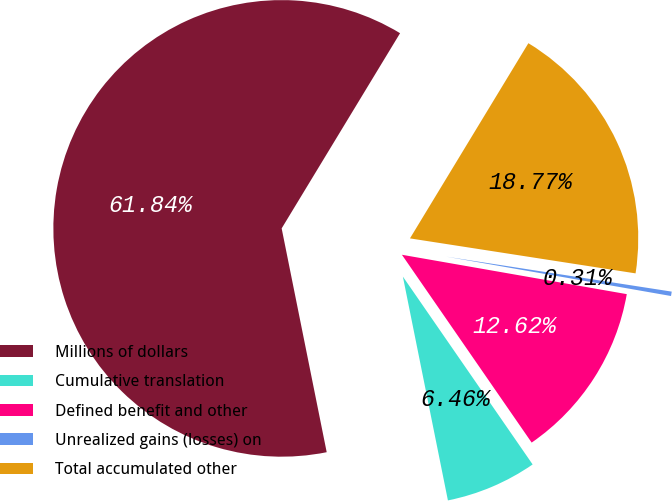<chart> <loc_0><loc_0><loc_500><loc_500><pie_chart><fcel>Millions of dollars<fcel>Cumulative translation<fcel>Defined benefit and other<fcel>Unrealized gains (losses) on<fcel>Total accumulated other<nl><fcel>61.84%<fcel>6.46%<fcel>12.62%<fcel>0.31%<fcel>18.77%<nl></chart> 